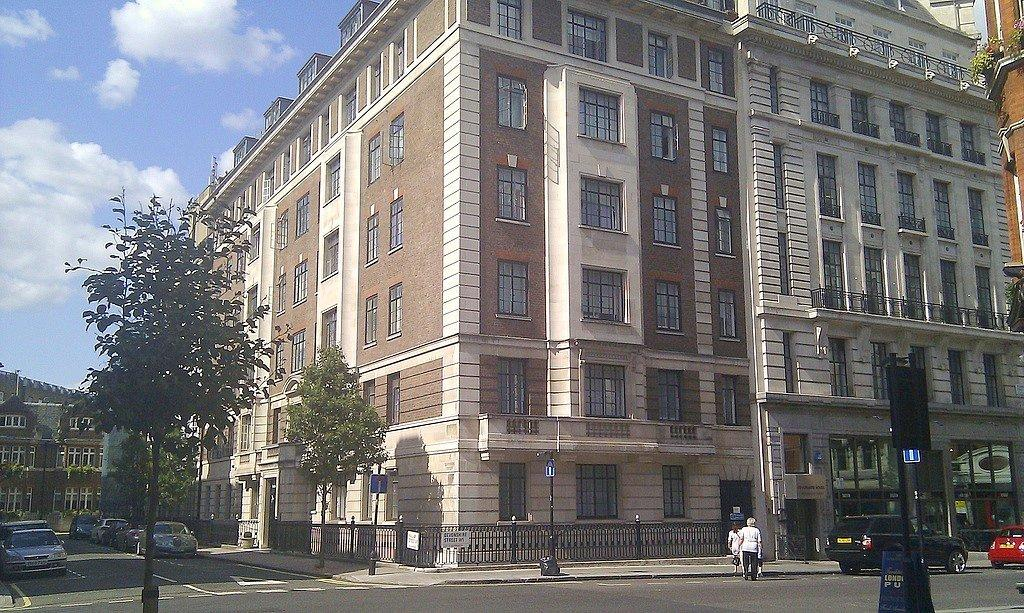What can be seen in the sky in the image? The sky with clouds is visible in the image. What type of vegetation is present in the image? There are trees and plants in the image. What type of structures can be seen in the image? There are buildings, street poles, and sign boards in the image. What type of lighting is present in the image? Street lights are visible in the image. What type of waste disposal containers are present in the image? Bins are present in the image. What type of transportation is on the road in the image? Motor vehicles are on the road in the image. Are there any people visible in the image? Yes, people are visible in the image. What type of produce is being harvested by the tramp in the image? There is no tramp or produce present in the image. What type of weather is depicted in the image? The image does not depict any specific weather conditions; it only shows the sky with clouds. 